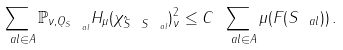<formula> <loc_0><loc_0><loc_500><loc_500>\sum _ { \ a l \in A } \| \mathbb { P } _ { \nu , Q _ { S _ { \ a l } } } H _ { \mu } ( \chi _ { \hat { S } \ S _ { \ a l } } ) \| _ { \nu } ^ { 2 } \leq C \, \sum _ { \ a l \in A } \mu ( F ( S _ { \ a l } ) ) \, .</formula> 